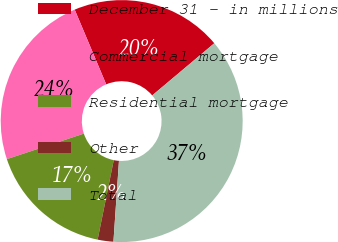<chart> <loc_0><loc_0><loc_500><loc_500><pie_chart><fcel>December 31 - in millions<fcel>Commercial mortgage<fcel>Residential mortgage<fcel>Other<fcel>Total<nl><fcel>20.23%<fcel>23.74%<fcel>16.72%<fcel>2.1%<fcel>37.21%<nl></chart> 